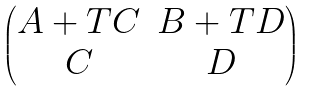Convert formula to latex. <formula><loc_0><loc_0><loc_500><loc_500>\begin{pmatrix} A + T C & B + T D \\ C & D \end{pmatrix}</formula> 